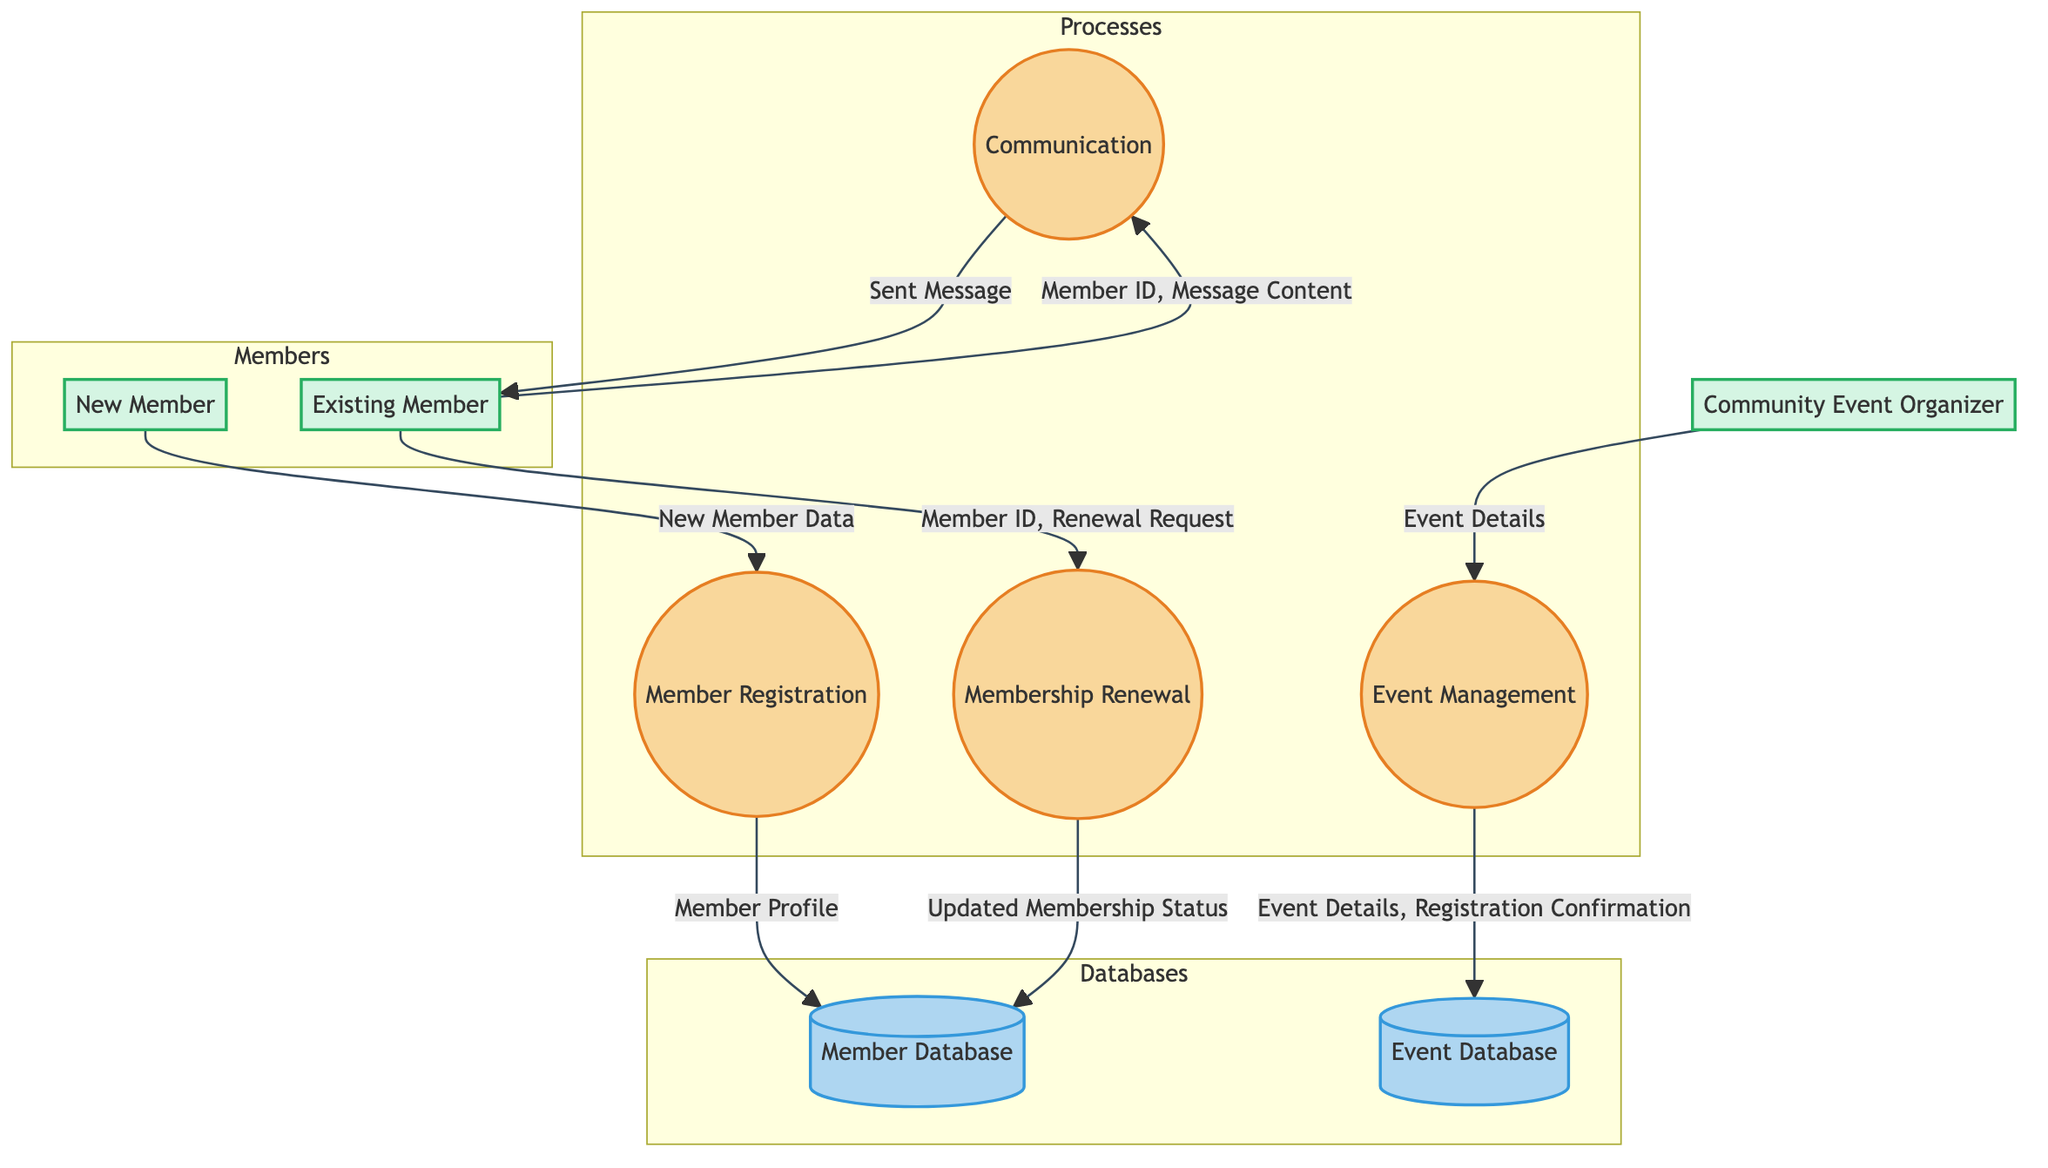What's the first process in the diagram? The first process in the diagram is "Member Registration." It is identified as the first node, with inputs from the external entity "New Member."
Answer: Member Registration How many processes are there in the diagram? There are four processes in the diagram: "Member Registration," "Membership Renewal," "Event Management," and "Communication." Counting each distinct process listed, we find a total of four.
Answer: 4 What data flows from "Event Management" to "Event Database"? The data that flows from "Event Management" to "Event Database" includes "Event Details" and "Event Registration Confirmation." This is shown as a joint data flow connecting these two nodes.
Answer: Event Details, Event Registration Confirmation Which external entity submits "Renewal Request" data? The external entity that submits "Renewal Request" data is "Existing Member." This is indicated in the connection to the "Membership Renewal" process where they provide the necessary inputs.
Answer: Existing Member What is the output of the "Communication" process? The output of the "Communication" process is "Sent Message." This output corresponds to the operation of sending a message based on inputs received.
Answer: Sent Message How does a "New Member" enter the system? A "New Member" enters the system by providing "New Member Data" to the "Member Registration" process. This flow illustrates the initiation of the membership process.
Answer: New Member Data What two data items are stored in the “Member Database”? The two data items stored in the "Member Database" are "Member Profile" and "Membership Status," which are both essential for managing member information and status updates.
Answer: Member Profile, Membership Status Which process handles event details provided by the "Community Event Organizer"? The process that handles event details provided by the "Community Event Organizer" is the "Event Management" process. This link is clearly illustrated in the flow from the organizer to Event Management.
Answer: Event Management What is the purpose of the "Membership Renewal" process? The purpose of the "Membership Renewal" process is to update the membership status based on the inputs received from the existing member, indicated by data flows to and from the member database.
Answer: Update Membership Status 